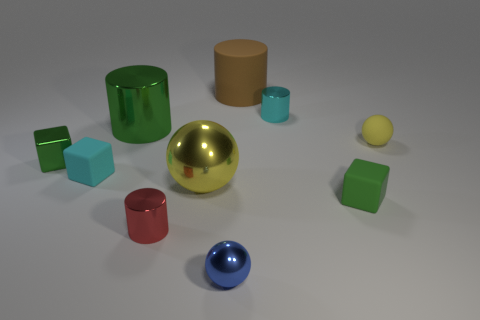Subtract all cylinders. How many objects are left? 6 Add 3 green rubber cubes. How many green rubber cubes are left? 4 Add 9 tiny yellow matte balls. How many tiny yellow matte balls exist? 10 Subtract 1 cyan cylinders. How many objects are left? 9 Subtract all tiny blocks. Subtract all red cylinders. How many objects are left? 6 